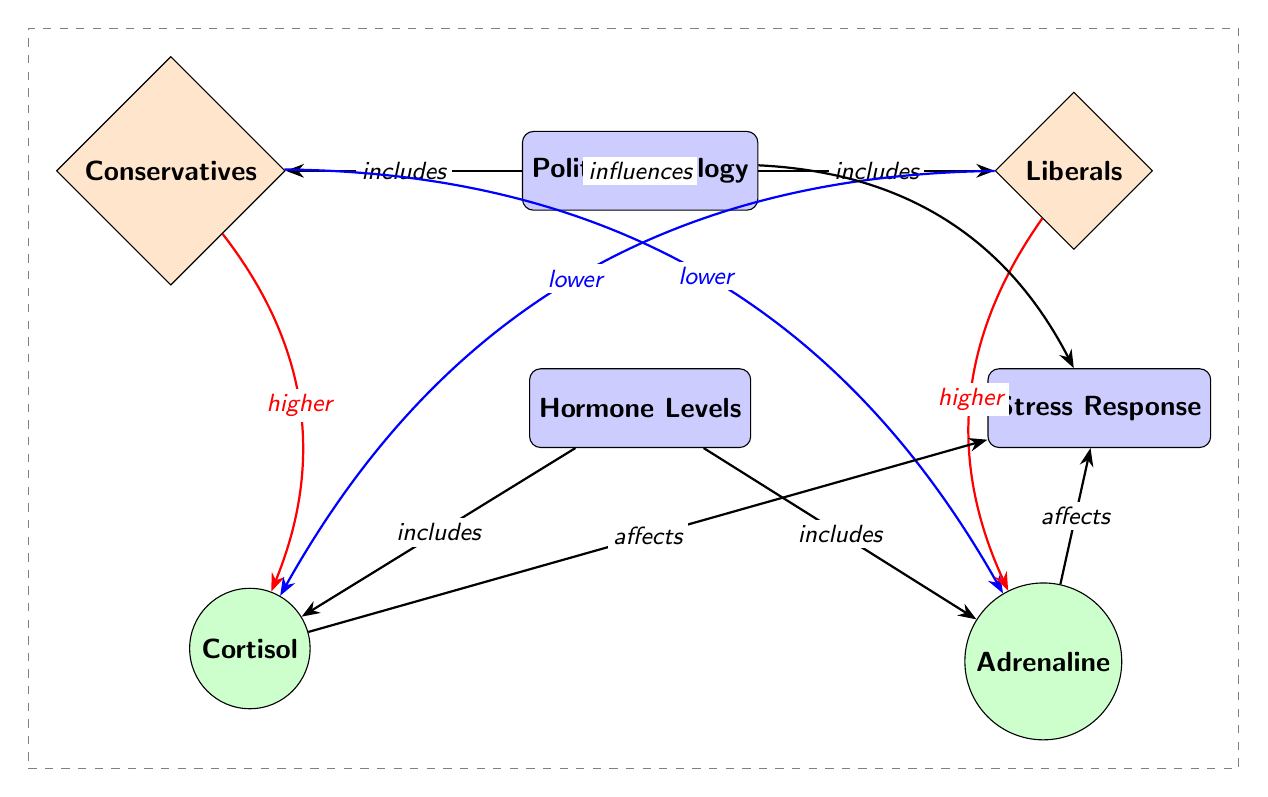What are the two political groups depicted in the diagram? The diagram shows two political groups: Conservatives and Liberals. These are represented as diamond shapes on either side of the central node labeled Political Ideology.
Answer: Conservatives and Liberals Which hormone is indicated to be higher in Conservatives? The diagram shows that cortisol levels are indicated to be higher in Conservatives, as shown by the red arrow pointing from Conservatives to cortisol.
Answer: Cortisol What does the arrow from Hormone Levels to Stress Response indicate? The arrow indicates that Hormone Levels affect Stress Response, which is represented by an arrow connecting these two nodes in the diagram.
Answer: Affects What is the relationship between Liberals and Adrenaline levels? The diagram indicates that Liberals have higher adrenaline levels, evidenced by the red arrow pointing from Liberals to adrenaline, showing a relationship of higher adrenaline among Liberals.
Answer: Higher How many hormones are represented in the diagram? The diagram shows two hormones: cortisol and adrenaline, which are represented as circle nodes under Hormone Levels.
Answer: Two Explain how Political Ideology influences Stress Response according to the diagram. The diagram shows that the Political Ideology node has a direct arrow leading to the Stress Response node, indicating that political ideology has an influence on stress response through the pathways of hormone levels.
Answer: Influences What hormonal change is associated with higher stress response in the context of Conservatives? The diagram indicates that higher cortisol levels are associated with higher stress response in Conservatives, as there is a pathway leading from cortisol to stress response.
Answer: Cortisol Which hormone is associated with a lower level in Conservatives? The diagram shows that adrenaline levels are indicated to be lower in Conservatives, as shown by the blue arrow pointing from Conservatives to adrenaline.
Answer: Adrenaline 